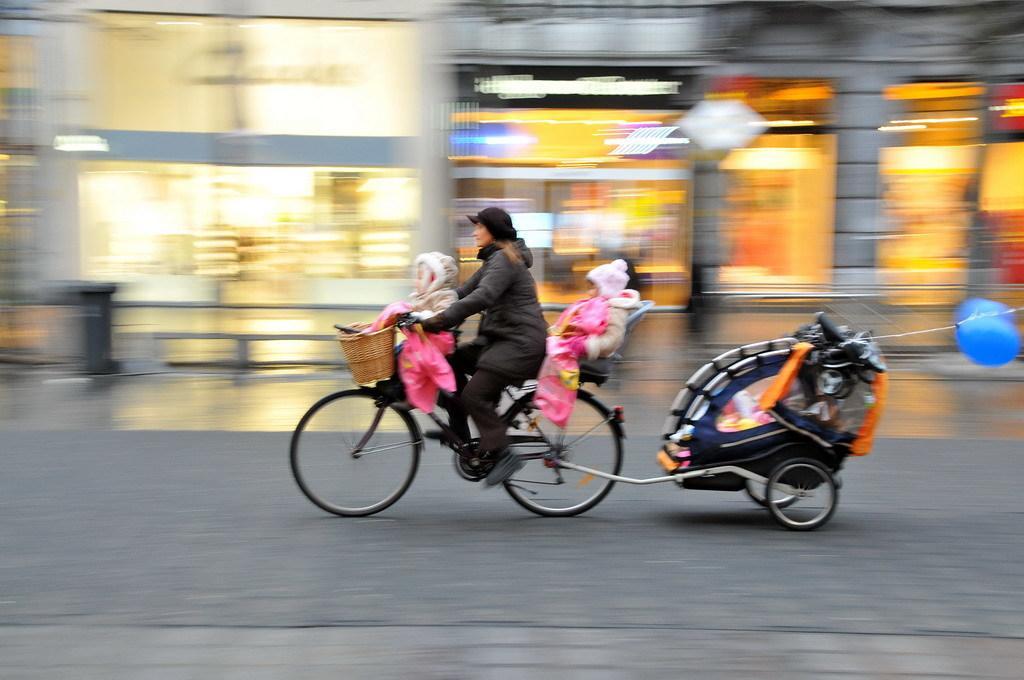Can you describe this image briefly? In this image I can see a woman and two children are on a cycle. I can also see few balloons. 